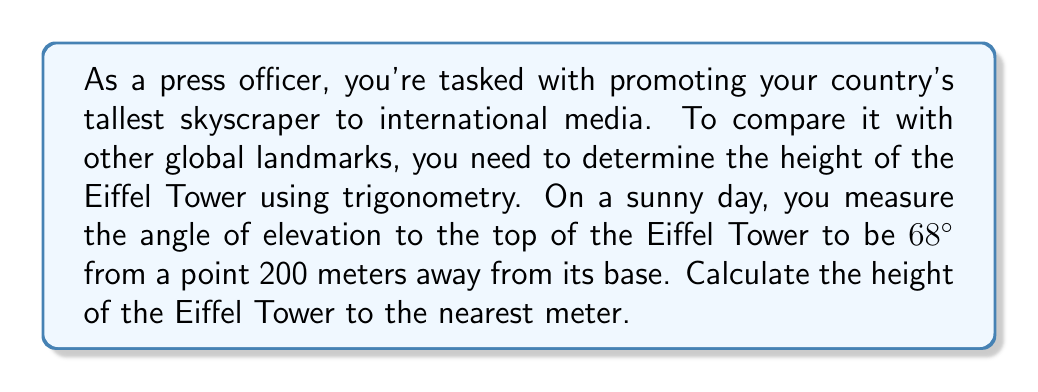Teach me how to tackle this problem. Let's approach this step-by-step using trigonometry:

1) First, let's visualize the problem:

[asy]
import geometry;

pair A = (0,0);
pair B = (200,0);
pair C = (0,500);

draw(A--B--C--A);

label("200 m", (100,0), S);
label("68°", (0,0), NW);
label("h", (0,250), W);

draw(rightanglemark(A,B,C,20));
[/asy]

2) We can see that this forms a right-angled triangle, where:
   - The adjacent side is 200 meters (the distance from the observation point to the base)
   - The angle of elevation is 68°
   - The opposite side is the height of the Eiffel Tower (what we're trying to find)

3) In this case, we need to use the tangent function, as we're relating the opposite side to the adjacent side:

   $$\tan(\theta) = \frac{\text{opposite}}{\text{adjacent}}$$

4) Plugging in our known values:

   $$\tan(68°) = \frac{h}{200}$$

   Where $h$ is the height of the Eiffel Tower.

5) To solve for $h$, we multiply both sides by 200:

   $$200 \cdot \tan(68°) = h$$

6) Now we can calculate:

   $$h = 200 \cdot \tan(68°) \approx 200 \cdot 2.4751 \approx 495.02\text{ meters}$$

7) Rounding to the nearest meter:

   $$h \approx 495\text{ meters}$$
Answer: The height of the Eiffel Tower is approximately 495 meters. 